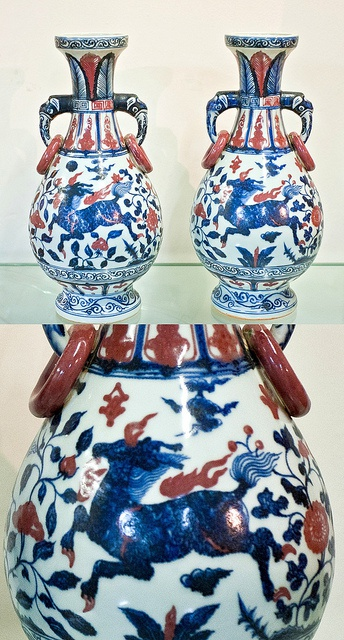Describe the objects in this image and their specific colors. I can see vase in ivory, lightgray, navy, black, and lightblue tones, vase in ivory, lightgray, blue, darkgray, and brown tones, and vase in ivory, white, darkgray, brown, and blue tones in this image. 